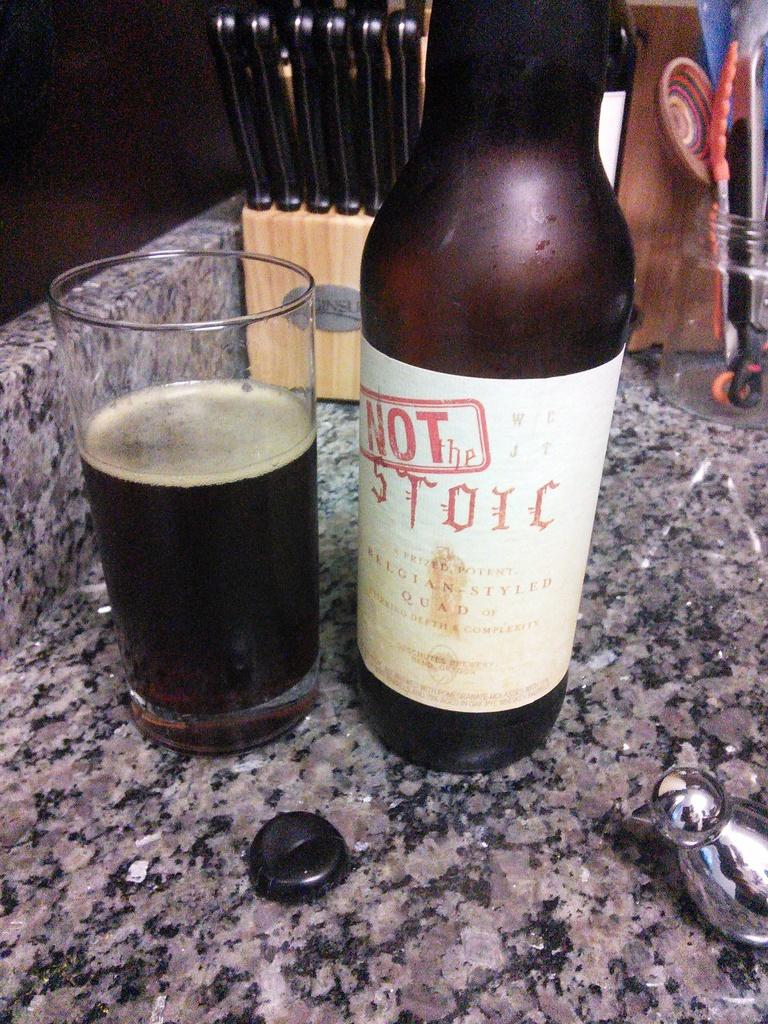What is one of the objects visible in the image? There is a bottle in the image. What else can be seen in the image related to beverages? There is a glass with a drink in the image. What items are present for eating or serving food? There are utensils in the image. Are there any other objects visible in the image? Yes, there are other objects in the image. How many oranges are on the table in the image? There are no oranges present in the image. Can you see a giraffe in the background of the image? There is no giraffe visible in the image. 